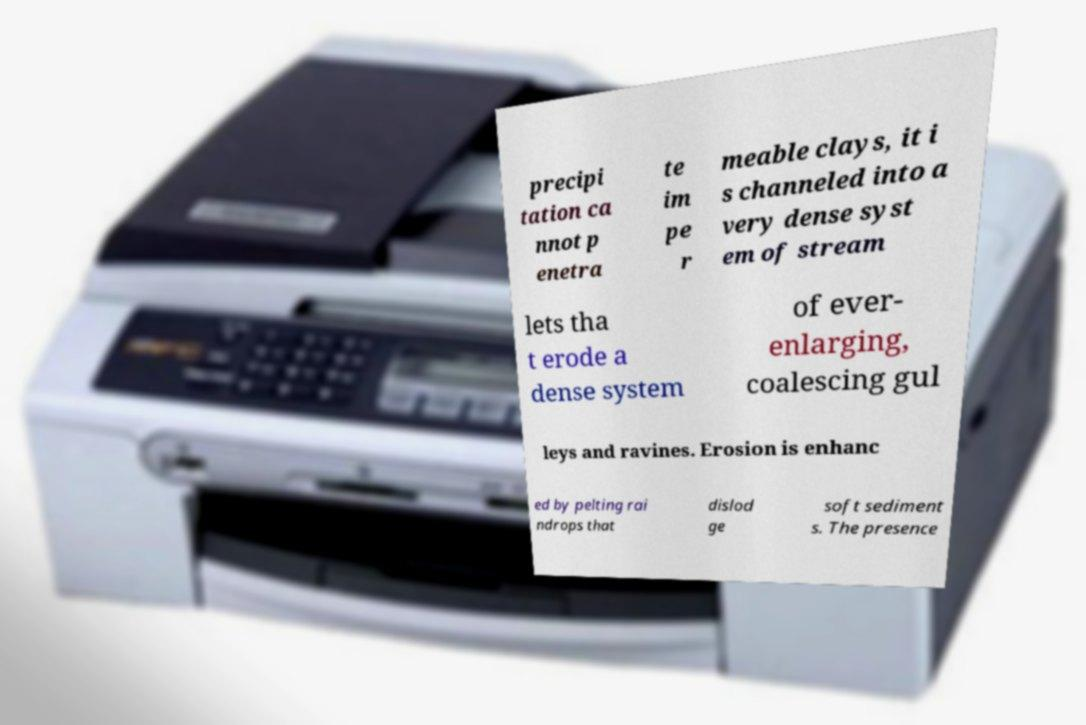What messages or text are displayed in this image? I need them in a readable, typed format. precipi tation ca nnot p enetra te im pe r meable clays, it i s channeled into a very dense syst em of stream lets tha t erode a dense system of ever- enlarging, coalescing gul leys and ravines. Erosion is enhanc ed by pelting rai ndrops that dislod ge soft sediment s. The presence 